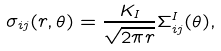<formula> <loc_0><loc_0><loc_500><loc_500>\sigma _ { i j } ( r , \theta ) = \frac { K _ { I } } { \sqrt { 2 \pi r } } \Sigma ^ { I } _ { i j } ( \theta ) ,</formula> 